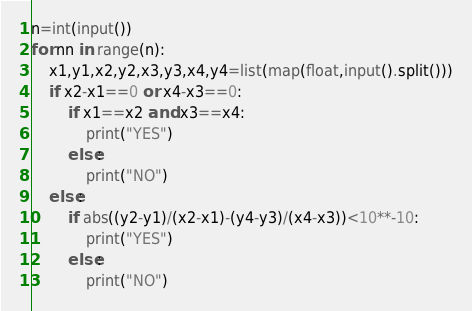<code> <loc_0><loc_0><loc_500><loc_500><_Python_>n=int(input())
for nn in range(n):
    x1,y1,x2,y2,x3,y3,x4,y4=list(map(float,input().split()))
    if x2-x1==0 or x4-x3==0:
        if x1==x2 and x3==x4:
            print("YES")
        else:
            print("NO")
    else:
        if abs((y2-y1)/(x2-x1)-(y4-y3)/(x4-x3))<10**-10:
            print("YES")
        else:
            print("NO")
</code> 